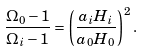<formula> <loc_0><loc_0><loc_500><loc_500>\frac { \Omega _ { 0 } - 1 } { \Omega _ { i } - 1 } = \left ( \frac { a _ { i } H _ { i } } { a _ { 0 } H _ { 0 } } \right ) ^ { 2 } .</formula> 